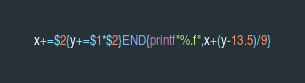Convert code to text. <code><loc_0><loc_0><loc_500><loc_500><_Awk_>x+=$2{y+=$1*$2}END{printf"%.f",x+(y-13.5)/9}</code> 